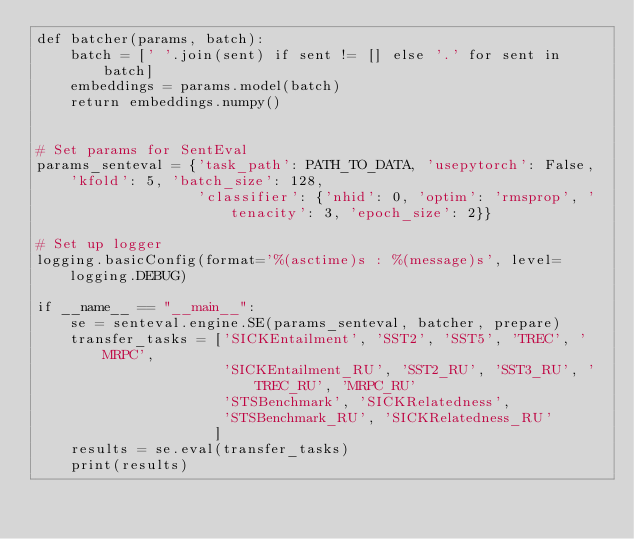Convert code to text. <code><loc_0><loc_0><loc_500><loc_500><_Python_>def batcher(params, batch):
    batch = [' '.join(sent) if sent != [] else '.' for sent in batch]
    embeddings = params.model(batch)
    return embeddings.numpy()


# Set params for SentEval
params_senteval = {'task_path': PATH_TO_DATA, 'usepytorch': False, 'kfold': 5, 'batch_size': 128,
                   'classifier': {'nhid': 0, 'optim': 'rmsprop', 'tenacity': 3, 'epoch_size': 2}}

# Set up logger
logging.basicConfig(format='%(asctime)s : %(message)s', level=logging.DEBUG)

if __name__ == "__main__":
    se = senteval.engine.SE(params_senteval, batcher, prepare)
    transfer_tasks = ['SICKEntailment', 'SST2', 'SST5', 'TREC', 'MRPC',
                      'SICKEntailment_RU', 'SST2_RU', 'SST3_RU', 'TREC_RU', 'MRPC_RU'
                      'STSBenchmark', 'SICKRelatedness',
                      'STSBenchmark_RU', 'SICKRelatedness_RU'
                     ]
    results = se.eval(transfer_tasks)
    print(results)
</code> 